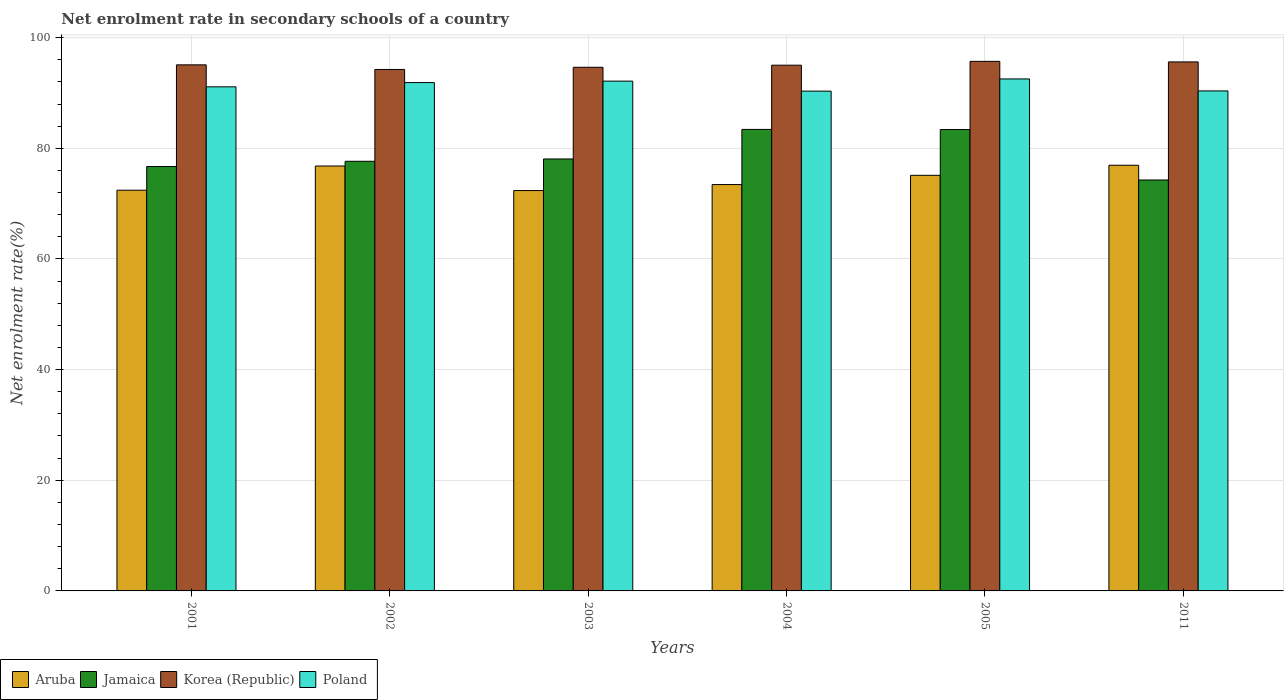Are the number of bars on each tick of the X-axis equal?
Your answer should be compact. Yes. How many bars are there on the 4th tick from the left?
Provide a succinct answer. 4. How many bars are there on the 3rd tick from the right?
Offer a very short reply. 4. What is the label of the 3rd group of bars from the left?
Your answer should be very brief. 2003. What is the net enrolment rate in secondary schools in Korea (Republic) in 2003?
Keep it short and to the point. 94.64. Across all years, what is the maximum net enrolment rate in secondary schools in Korea (Republic)?
Ensure brevity in your answer.  95.71. Across all years, what is the minimum net enrolment rate in secondary schools in Poland?
Keep it short and to the point. 90.33. What is the total net enrolment rate in secondary schools in Aruba in the graph?
Keep it short and to the point. 447.08. What is the difference between the net enrolment rate in secondary schools in Jamaica in 2001 and that in 2002?
Your response must be concise. -0.95. What is the difference between the net enrolment rate in secondary schools in Korea (Republic) in 2005 and the net enrolment rate in secondary schools in Jamaica in 2001?
Your response must be concise. 19.01. What is the average net enrolment rate in secondary schools in Aruba per year?
Ensure brevity in your answer.  74.51. In the year 2003, what is the difference between the net enrolment rate in secondary schools in Korea (Republic) and net enrolment rate in secondary schools in Aruba?
Your response must be concise. 22.28. What is the ratio of the net enrolment rate in secondary schools in Jamaica in 2004 to that in 2005?
Your response must be concise. 1. Is the net enrolment rate in secondary schools in Jamaica in 2004 less than that in 2011?
Your response must be concise. No. What is the difference between the highest and the second highest net enrolment rate in secondary schools in Korea (Republic)?
Your answer should be compact. 0.1. What is the difference between the highest and the lowest net enrolment rate in secondary schools in Aruba?
Offer a very short reply. 4.58. In how many years, is the net enrolment rate in secondary schools in Jamaica greater than the average net enrolment rate in secondary schools in Jamaica taken over all years?
Ensure brevity in your answer.  2. Is the sum of the net enrolment rate in secondary schools in Korea (Republic) in 2001 and 2011 greater than the maximum net enrolment rate in secondary schools in Poland across all years?
Offer a very short reply. Yes. Is it the case that in every year, the sum of the net enrolment rate in secondary schools in Korea (Republic) and net enrolment rate in secondary schools in Poland is greater than the sum of net enrolment rate in secondary schools in Jamaica and net enrolment rate in secondary schools in Aruba?
Your response must be concise. Yes. What does the 2nd bar from the left in 2011 represents?
Provide a succinct answer. Jamaica. What does the 3rd bar from the right in 2002 represents?
Your response must be concise. Jamaica. How many bars are there?
Keep it short and to the point. 24. What is the difference between two consecutive major ticks on the Y-axis?
Ensure brevity in your answer.  20. Are the values on the major ticks of Y-axis written in scientific E-notation?
Offer a terse response. No. Does the graph contain any zero values?
Your answer should be very brief. No. Where does the legend appear in the graph?
Make the answer very short. Bottom left. How are the legend labels stacked?
Offer a terse response. Horizontal. What is the title of the graph?
Provide a short and direct response. Net enrolment rate in secondary schools of a country. Does "Virgin Islands" appear as one of the legend labels in the graph?
Your answer should be compact. No. What is the label or title of the Y-axis?
Your response must be concise. Net enrolment rate(%). What is the Net enrolment rate(%) in Aruba in 2001?
Your response must be concise. 72.42. What is the Net enrolment rate(%) in Jamaica in 2001?
Provide a succinct answer. 76.7. What is the Net enrolment rate(%) in Korea (Republic) in 2001?
Provide a succinct answer. 95.08. What is the Net enrolment rate(%) in Poland in 2001?
Your answer should be very brief. 91.11. What is the Net enrolment rate(%) of Aruba in 2002?
Provide a short and direct response. 76.8. What is the Net enrolment rate(%) of Jamaica in 2002?
Your answer should be compact. 77.65. What is the Net enrolment rate(%) of Korea (Republic) in 2002?
Offer a terse response. 94.25. What is the Net enrolment rate(%) of Poland in 2002?
Offer a very short reply. 91.88. What is the Net enrolment rate(%) in Aruba in 2003?
Provide a short and direct response. 72.36. What is the Net enrolment rate(%) of Jamaica in 2003?
Provide a succinct answer. 78.07. What is the Net enrolment rate(%) of Korea (Republic) in 2003?
Ensure brevity in your answer.  94.64. What is the Net enrolment rate(%) of Poland in 2003?
Your answer should be very brief. 92.14. What is the Net enrolment rate(%) in Aruba in 2004?
Ensure brevity in your answer.  73.44. What is the Net enrolment rate(%) of Jamaica in 2004?
Provide a short and direct response. 83.41. What is the Net enrolment rate(%) in Korea (Republic) in 2004?
Make the answer very short. 95.02. What is the Net enrolment rate(%) of Poland in 2004?
Your answer should be very brief. 90.33. What is the Net enrolment rate(%) of Aruba in 2005?
Give a very brief answer. 75.11. What is the Net enrolment rate(%) of Jamaica in 2005?
Provide a succinct answer. 83.39. What is the Net enrolment rate(%) in Korea (Republic) in 2005?
Ensure brevity in your answer.  95.71. What is the Net enrolment rate(%) in Poland in 2005?
Your answer should be compact. 92.53. What is the Net enrolment rate(%) of Aruba in 2011?
Offer a very short reply. 76.94. What is the Net enrolment rate(%) of Jamaica in 2011?
Your answer should be very brief. 74.27. What is the Net enrolment rate(%) in Korea (Republic) in 2011?
Ensure brevity in your answer.  95.61. What is the Net enrolment rate(%) in Poland in 2011?
Your answer should be very brief. 90.37. Across all years, what is the maximum Net enrolment rate(%) in Aruba?
Make the answer very short. 76.94. Across all years, what is the maximum Net enrolment rate(%) in Jamaica?
Offer a very short reply. 83.41. Across all years, what is the maximum Net enrolment rate(%) in Korea (Republic)?
Your answer should be compact. 95.71. Across all years, what is the maximum Net enrolment rate(%) in Poland?
Keep it short and to the point. 92.53. Across all years, what is the minimum Net enrolment rate(%) of Aruba?
Your response must be concise. 72.36. Across all years, what is the minimum Net enrolment rate(%) of Jamaica?
Provide a short and direct response. 74.27. Across all years, what is the minimum Net enrolment rate(%) in Korea (Republic)?
Provide a short and direct response. 94.25. Across all years, what is the minimum Net enrolment rate(%) of Poland?
Give a very brief answer. 90.33. What is the total Net enrolment rate(%) of Aruba in the graph?
Offer a very short reply. 447.08. What is the total Net enrolment rate(%) in Jamaica in the graph?
Your answer should be compact. 473.5. What is the total Net enrolment rate(%) of Korea (Republic) in the graph?
Offer a very short reply. 570.31. What is the total Net enrolment rate(%) of Poland in the graph?
Ensure brevity in your answer.  548.36. What is the difference between the Net enrolment rate(%) of Aruba in 2001 and that in 2002?
Ensure brevity in your answer.  -4.37. What is the difference between the Net enrolment rate(%) in Jamaica in 2001 and that in 2002?
Your answer should be very brief. -0.95. What is the difference between the Net enrolment rate(%) in Korea (Republic) in 2001 and that in 2002?
Make the answer very short. 0.83. What is the difference between the Net enrolment rate(%) in Poland in 2001 and that in 2002?
Keep it short and to the point. -0.77. What is the difference between the Net enrolment rate(%) of Aruba in 2001 and that in 2003?
Provide a succinct answer. 0.06. What is the difference between the Net enrolment rate(%) in Jamaica in 2001 and that in 2003?
Ensure brevity in your answer.  -1.37. What is the difference between the Net enrolment rate(%) in Korea (Republic) in 2001 and that in 2003?
Make the answer very short. 0.44. What is the difference between the Net enrolment rate(%) of Poland in 2001 and that in 2003?
Keep it short and to the point. -1.03. What is the difference between the Net enrolment rate(%) in Aruba in 2001 and that in 2004?
Give a very brief answer. -1.02. What is the difference between the Net enrolment rate(%) of Jamaica in 2001 and that in 2004?
Your answer should be compact. -6.71. What is the difference between the Net enrolment rate(%) in Korea (Republic) in 2001 and that in 2004?
Your answer should be compact. 0.06. What is the difference between the Net enrolment rate(%) of Poland in 2001 and that in 2004?
Keep it short and to the point. 0.78. What is the difference between the Net enrolment rate(%) in Aruba in 2001 and that in 2005?
Your answer should be compact. -2.69. What is the difference between the Net enrolment rate(%) of Jamaica in 2001 and that in 2005?
Provide a short and direct response. -6.69. What is the difference between the Net enrolment rate(%) of Korea (Republic) in 2001 and that in 2005?
Offer a terse response. -0.63. What is the difference between the Net enrolment rate(%) in Poland in 2001 and that in 2005?
Your response must be concise. -1.42. What is the difference between the Net enrolment rate(%) in Aruba in 2001 and that in 2011?
Your answer should be compact. -4.51. What is the difference between the Net enrolment rate(%) in Jamaica in 2001 and that in 2011?
Ensure brevity in your answer.  2.43. What is the difference between the Net enrolment rate(%) of Korea (Republic) in 2001 and that in 2011?
Your answer should be compact. -0.53. What is the difference between the Net enrolment rate(%) of Poland in 2001 and that in 2011?
Offer a terse response. 0.74. What is the difference between the Net enrolment rate(%) in Aruba in 2002 and that in 2003?
Keep it short and to the point. 4.44. What is the difference between the Net enrolment rate(%) of Jamaica in 2002 and that in 2003?
Make the answer very short. -0.42. What is the difference between the Net enrolment rate(%) of Korea (Republic) in 2002 and that in 2003?
Your answer should be compact. -0.39. What is the difference between the Net enrolment rate(%) in Poland in 2002 and that in 2003?
Provide a short and direct response. -0.26. What is the difference between the Net enrolment rate(%) of Aruba in 2002 and that in 2004?
Ensure brevity in your answer.  3.35. What is the difference between the Net enrolment rate(%) of Jamaica in 2002 and that in 2004?
Keep it short and to the point. -5.76. What is the difference between the Net enrolment rate(%) of Korea (Republic) in 2002 and that in 2004?
Keep it short and to the point. -0.77. What is the difference between the Net enrolment rate(%) of Poland in 2002 and that in 2004?
Provide a short and direct response. 1.54. What is the difference between the Net enrolment rate(%) in Aruba in 2002 and that in 2005?
Your answer should be compact. 1.68. What is the difference between the Net enrolment rate(%) in Jamaica in 2002 and that in 2005?
Your answer should be compact. -5.74. What is the difference between the Net enrolment rate(%) of Korea (Republic) in 2002 and that in 2005?
Offer a very short reply. -1.46. What is the difference between the Net enrolment rate(%) in Poland in 2002 and that in 2005?
Provide a succinct answer. -0.66. What is the difference between the Net enrolment rate(%) in Aruba in 2002 and that in 2011?
Your answer should be compact. -0.14. What is the difference between the Net enrolment rate(%) in Jamaica in 2002 and that in 2011?
Provide a succinct answer. 3.38. What is the difference between the Net enrolment rate(%) of Korea (Republic) in 2002 and that in 2011?
Offer a terse response. -1.36. What is the difference between the Net enrolment rate(%) in Poland in 2002 and that in 2011?
Offer a very short reply. 1.51. What is the difference between the Net enrolment rate(%) in Aruba in 2003 and that in 2004?
Keep it short and to the point. -1.08. What is the difference between the Net enrolment rate(%) of Jamaica in 2003 and that in 2004?
Offer a very short reply. -5.34. What is the difference between the Net enrolment rate(%) in Korea (Republic) in 2003 and that in 2004?
Your answer should be very brief. -0.38. What is the difference between the Net enrolment rate(%) of Poland in 2003 and that in 2004?
Your response must be concise. 1.81. What is the difference between the Net enrolment rate(%) in Aruba in 2003 and that in 2005?
Give a very brief answer. -2.75. What is the difference between the Net enrolment rate(%) in Jamaica in 2003 and that in 2005?
Keep it short and to the point. -5.32. What is the difference between the Net enrolment rate(%) of Korea (Republic) in 2003 and that in 2005?
Provide a succinct answer. -1.07. What is the difference between the Net enrolment rate(%) in Poland in 2003 and that in 2005?
Ensure brevity in your answer.  -0.39. What is the difference between the Net enrolment rate(%) of Aruba in 2003 and that in 2011?
Make the answer very short. -4.58. What is the difference between the Net enrolment rate(%) of Jamaica in 2003 and that in 2011?
Make the answer very short. 3.8. What is the difference between the Net enrolment rate(%) of Korea (Republic) in 2003 and that in 2011?
Your answer should be compact. -0.97. What is the difference between the Net enrolment rate(%) of Poland in 2003 and that in 2011?
Your answer should be very brief. 1.77. What is the difference between the Net enrolment rate(%) of Aruba in 2004 and that in 2005?
Provide a succinct answer. -1.67. What is the difference between the Net enrolment rate(%) of Jamaica in 2004 and that in 2005?
Offer a very short reply. 0.02. What is the difference between the Net enrolment rate(%) in Korea (Republic) in 2004 and that in 2005?
Provide a succinct answer. -0.7. What is the difference between the Net enrolment rate(%) in Poland in 2004 and that in 2005?
Give a very brief answer. -2.2. What is the difference between the Net enrolment rate(%) of Aruba in 2004 and that in 2011?
Make the answer very short. -3.49. What is the difference between the Net enrolment rate(%) in Jamaica in 2004 and that in 2011?
Provide a succinct answer. 9.14. What is the difference between the Net enrolment rate(%) in Korea (Republic) in 2004 and that in 2011?
Offer a very short reply. -0.59. What is the difference between the Net enrolment rate(%) in Poland in 2004 and that in 2011?
Your answer should be compact. -0.04. What is the difference between the Net enrolment rate(%) in Aruba in 2005 and that in 2011?
Provide a short and direct response. -1.82. What is the difference between the Net enrolment rate(%) in Jamaica in 2005 and that in 2011?
Provide a succinct answer. 9.12. What is the difference between the Net enrolment rate(%) in Korea (Republic) in 2005 and that in 2011?
Ensure brevity in your answer.  0.1. What is the difference between the Net enrolment rate(%) in Poland in 2005 and that in 2011?
Give a very brief answer. 2.17. What is the difference between the Net enrolment rate(%) in Aruba in 2001 and the Net enrolment rate(%) in Jamaica in 2002?
Your answer should be compact. -5.23. What is the difference between the Net enrolment rate(%) in Aruba in 2001 and the Net enrolment rate(%) in Korea (Republic) in 2002?
Keep it short and to the point. -21.82. What is the difference between the Net enrolment rate(%) in Aruba in 2001 and the Net enrolment rate(%) in Poland in 2002?
Offer a terse response. -19.45. What is the difference between the Net enrolment rate(%) in Jamaica in 2001 and the Net enrolment rate(%) in Korea (Republic) in 2002?
Provide a succinct answer. -17.54. What is the difference between the Net enrolment rate(%) in Jamaica in 2001 and the Net enrolment rate(%) in Poland in 2002?
Offer a terse response. -15.17. What is the difference between the Net enrolment rate(%) in Korea (Republic) in 2001 and the Net enrolment rate(%) in Poland in 2002?
Keep it short and to the point. 3.2. What is the difference between the Net enrolment rate(%) in Aruba in 2001 and the Net enrolment rate(%) in Jamaica in 2003?
Keep it short and to the point. -5.65. What is the difference between the Net enrolment rate(%) in Aruba in 2001 and the Net enrolment rate(%) in Korea (Republic) in 2003?
Provide a succinct answer. -22.22. What is the difference between the Net enrolment rate(%) in Aruba in 2001 and the Net enrolment rate(%) in Poland in 2003?
Provide a succinct answer. -19.71. What is the difference between the Net enrolment rate(%) of Jamaica in 2001 and the Net enrolment rate(%) of Korea (Republic) in 2003?
Offer a very short reply. -17.94. What is the difference between the Net enrolment rate(%) in Jamaica in 2001 and the Net enrolment rate(%) in Poland in 2003?
Keep it short and to the point. -15.43. What is the difference between the Net enrolment rate(%) in Korea (Republic) in 2001 and the Net enrolment rate(%) in Poland in 2003?
Give a very brief answer. 2.94. What is the difference between the Net enrolment rate(%) of Aruba in 2001 and the Net enrolment rate(%) of Jamaica in 2004?
Give a very brief answer. -10.99. What is the difference between the Net enrolment rate(%) in Aruba in 2001 and the Net enrolment rate(%) in Korea (Republic) in 2004?
Your answer should be compact. -22.59. What is the difference between the Net enrolment rate(%) in Aruba in 2001 and the Net enrolment rate(%) in Poland in 2004?
Your answer should be compact. -17.91. What is the difference between the Net enrolment rate(%) of Jamaica in 2001 and the Net enrolment rate(%) of Korea (Republic) in 2004?
Your response must be concise. -18.31. What is the difference between the Net enrolment rate(%) in Jamaica in 2001 and the Net enrolment rate(%) in Poland in 2004?
Ensure brevity in your answer.  -13.63. What is the difference between the Net enrolment rate(%) of Korea (Republic) in 2001 and the Net enrolment rate(%) of Poland in 2004?
Your response must be concise. 4.75. What is the difference between the Net enrolment rate(%) in Aruba in 2001 and the Net enrolment rate(%) in Jamaica in 2005?
Make the answer very short. -10.97. What is the difference between the Net enrolment rate(%) in Aruba in 2001 and the Net enrolment rate(%) in Korea (Republic) in 2005?
Make the answer very short. -23.29. What is the difference between the Net enrolment rate(%) of Aruba in 2001 and the Net enrolment rate(%) of Poland in 2005?
Make the answer very short. -20.11. What is the difference between the Net enrolment rate(%) of Jamaica in 2001 and the Net enrolment rate(%) of Korea (Republic) in 2005?
Offer a terse response. -19.01. What is the difference between the Net enrolment rate(%) of Jamaica in 2001 and the Net enrolment rate(%) of Poland in 2005?
Your answer should be very brief. -15.83. What is the difference between the Net enrolment rate(%) of Korea (Republic) in 2001 and the Net enrolment rate(%) of Poland in 2005?
Provide a short and direct response. 2.55. What is the difference between the Net enrolment rate(%) in Aruba in 2001 and the Net enrolment rate(%) in Jamaica in 2011?
Make the answer very short. -1.85. What is the difference between the Net enrolment rate(%) in Aruba in 2001 and the Net enrolment rate(%) in Korea (Republic) in 2011?
Make the answer very short. -23.19. What is the difference between the Net enrolment rate(%) in Aruba in 2001 and the Net enrolment rate(%) in Poland in 2011?
Your answer should be compact. -17.94. What is the difference between the Net enrolment rate(%) of Jamaica in 2001 and the Net enrolment rate(%) of Korea (Republic) in 2011?
Offer a very short reply. -18.91. What is the difference between the Net enrolment rate(%) in Jamaica in 2001 and the Net enrolment rate(%) in Poland in 2011?
Make the answer very short. -13.66. What is the difference between the Net enrolment rate(%) of Korea (Republic) in 2001 and the Net enrolment rate(%) of Poland in 2011?
Provide a succinct answer. 4.71. What is the difference between the Net enrolment rate(%) in Aruba in 2002 and the Net enrolment rate(%) in Jamaica in 2003?
Your answer should be compact. -1.28. What is the difference between the Net enrolment rate(%) in Aruba in 2002 and the Net enrolment rate(%) in Korea (Republic) in 2003?
Your response must be concise. -17.85. What is the difference between the Net enrolment rate(%) of Aruba in 2002 and the Net enrolment rate(%) of Poland in 2003?
Keep it short and to the point. -15.34. What is the difference between the Net enrolment rate(%) of Jamaica in 2002 and the Net enrolment rate(%) of Korea (Republic) in 2003?
Make the answer very short. -16.99. What is the difference between the Net enrolment rate(%) of Jamaica in 2002 and the Net enrolment rate(%) of Poland in 2003?
Your answer should be compact. -14.49. What is the difference between the Net enrolment rate(%) of Korea (Republic) in 2002 and the Net enrolment rate(%) of Poland in 2003?
Your response must be concise. 2.11. What is the difference between the Net enrolment rate(%) in Aruba in 2002 and the Net enrolment rate(%) in Jamaica in 2004?
Provide a succinct answer. -6.62. What is the difference between the Net enrolment rate(%) of Aruba in 2002 and the Net enrolment rate(%) of Korea (Republic) in 2004?
Your response must be concise. -18.22. What is the difference between the Net enrolment rate(%) in Aruba in 2002 and the Net enrolment rate(%) in Poland in 2004?
Your answer should be compact. -13.54. What is the difference between the Net enrolment rate(%) of Jamaica in 2002 and the Net enrolment rate(%) of Korea (Republic) in 2004?
Make the answer very short. -17.37. What is the difference between the Net enrolment rate(%) in Jamaica in 2002 and the Net enrolment rate(%) in Poland in 2004?
Make the answer very short. -12.68. What is the difference between the Net enrolment rate(%) of Korea (Republic) in 2002 and the Net enrolment rate(%) of Poland in 2004?
Make the answer very short. 3.92. What is the difference between the Net enrolment rate(%) of Aruba in 2002 and the Net enrolment rate(%) of Jamaica in 2005?
Your response must be concise. -6.6. What is the difference between the Net enrolment rate(%) in Aruba in 2002 and the Net enrolment rate(%) in Korea (Republic) in 2005?
Your answer should be compact. -18.92. What is the difference between the Net enrolment rate(%) of Aruba in 2002 and the Net enrolment rate(%) of Poland in 2005?
Provide a short and direct response. -15.74. What is the difference between the Net enrolment rate(%) of Jamaica in 2002 and the Net enrolment rate(%) of Korea (Republic) in 2005?
Give a very brief answer. -18.06. What is the difference between the Net enrolment rate(%) of Jamaica in 2002 and the Net enrolment rate(%) of Poland in 2005?
Your answer should be very brief. -14.88. What is the difference between the Net enrolment rate(%) in Korea (Republic) in 2002 and the Net enrolment rate(%) in Poland in 2005?
Make the answer very short. 1.71. What is the difference between the Net enrolment rate(%) in Aruba in 2002 and the Net enrolment rate(%) in Jamaica in 2011?
Provide a succinct answer. 2.53. What is the difference between the Net enrolment rate(%) in Aruba in 2002 and the Net enrolment rate(%) in Korea (Republic) in 2011?
Keep it short and to the point. -18.81. What is the difference between the Net enrolment rate(%) in Aruba in 2002 and the Net enrolment rate(%) in Poland in 2011?
Ensure brevity in your answer.  -13.57. What is the difference between the Net enrolment rate(%) of Jamaica in 2002 and the Net enrolment rate(%) of Korea (Republic) in 2011?
Your answer should be compact. -17.96. What is the difference between the Net enrolment rate(%) of Jamaica in 2002 and the Net enrolment rate(%) of Poland in 2011?
Offer a very short reply. -12.72. What is the difference between the Net enrolment rate(%) in Korea (Republic) in 2002 and the Net enrolment rate(%) in Poland in 2011?
Provide a short and direct response. 3.88. What is the difference between the Net enrolment rate(%) in Aruba in 2003 and the Net enrolment rate(%) in Jamaica in 2004?
Keep it short and to the point. -11.05. What is the difference between the Net enrolment rate(%) in Aruba in 2003 and the Net enrolment rate(%) in Korea (Republic) in 2004?
Ensure brevity in your answer.  -22.66. What is the difference between the Net enrolment rate(%) of Aruba in 2003 and the Net enrolment rate(%) of Poland in 2004?
Ensure brevity in your answer.  -17.97. What is the difference between the Net enrolment rate(%) of Jamaica in 2003 and the Net enrolment rate(%) of Korea (Republic) in 2004?
Provide a succinct answer. -16.95. What is the difference between the Net enrolment rate(%) in Jamaica in 2003 and the Net enrolment rate(%) in Poland in 2004?
Ensure brevity in your answer.  -12.26. What is the difference between the Net enrolment rate(%) of Korea (Republic) in 2003 and the Net enrolment rate(%) of Poland in 2004?
Offer a very short reply. 4.31. What is the difference between the Net enrolment rate(%) of Aruba in 2003 and the Net enrolment rate(%) of Jamaica in 2005?
Provide a succinct answer. -11.03. What is the difference between the Net enrolment rate(%) of Aruba in 2003 and the Net enrolment rate(%) of Korea (Republic) in 2005?
Offer a very short reply. -23.35. What is the difference between the Net enrolment rate(%) in Aruba in 2003 and the Net enrolment rate(%) in Poland in 2005?
Provide a short and direct response. -20.17. What is the difference between the Net enrolment rate(%) in Jamaica in 2003 and the Net enrolment rate(%) in Korea (Republic) in 2005?
Ensure brevity in your answer.  -17.64. What is the difference between the Net enrolment rate(%) in Jamaica in 2003 and the Net enrolment rate(%) in Poland in 2005?
Your answer should be compact. -14.46. What is the difference between the Net enrolment rate(%) of Korea (Republic) in 2003 and the Net enrolment rate(%) of Poland in 2005?
Ensure brevity in your answer.  2.11. What is the difference between the Net enrolment rate(%) of Aruba in 2003 and the Net enrolment rate(%) of Jamaica in 2011?
Your response must be concise. -1.91. What is the difference between the Net enrolment rate(%) of Aruba in 2003 and the Net enrolment rate(%) of Korea (Republic) in 2011?
Offer a very short reply. -23.25. What is the difference between the Net enrolment rate(%) of Aruba in 2003 and the Net enrolment rate(%) of Poland in 2011?
Offer a terse response. -18.01. What is the difference between the Net enrolment rate(%) of Jamaica in 2003 and the Net enrolment rate(%) of Korea (Republic) in 2011?
Your answer should be compact. -17.54. What is the difference between the Net enrolment rate(%) in Jamaica in 2003 and the Net enrolment rate(%) in Poland in 2011?
Offer a very short reply. -12.29. What is the difference between the Net enrolment rate(%) of Korea (Republic) in 2003 and the Net enrolment rate(%) of Poland in 2011?
Provide a succinct answer. 4.28. What is the difference between the Net enrolment rate(%) in Aruba in 2004 and the Net enrolment rate(%) in Jamaica in 2005?
Provide a short and direct response. -9.95. What is the difference between the Net enrolment rate(%) of Aruba in 2004 and the Net enrolment rate(%) of Korea (Republic) in 2005?
Keep it short and to the point. -22.27. What is the difference between the Net enrolment rate(%) of Aruba in 2004 and the Net enrolment rate(%) of Poland in 2005?
Ensure brevity in your answer.  -19.09. What is the difference between the Net enrolment rate(%) of Jamaica in 2004 and the Net enrolment rate(%) of Korea (Republic) in 2005?
Make the answer very short. -12.3. What is the difference between the Net enrolment rate(%) of Jamaica in 2004 and the Net enrolment rate(%) of Poland in 2005?
Offer a terse response. -9.12. What is the difference between the Net enrolment rate(%) in Korea (Republic) in 2004 and the Net enrolment rate(%) in Poland in 2005?
Give a very brief answer. 2.48. What is the difference between the Net enrolment rate(%) in Aruba in 2004 and the Net enrolment rate(%) in Jamaica in 2011?
Your answer should be very brief. -0.82. What is the difference between the Net enrolment rate(%) of Aruba in 2004 and the Net enrolment rate(%) of Korea (Republic) in 2011?
Ensure brevity in your answer.  -22.16. What is the difference between the Net enrolment rate(%) in Aruba in 2004 and the Net enrolment rate(%) in Poland in 2011?
Provide a short and direct response. -16.92. What is the difference between the Net enrolment rate(%) in Jamaica in 2004 and the Net enrolment rate(%) in Korea (Republic) in 2011?
Ensure brevity in your answer.  -12.2. What is the difference between the Net enrolment rate(%) in Jamaica in 2004 and the Net enrolment rate(%) in Poland in 2011?
Make the answer very short. -6.95. What is the difference between the Net enrolment rate(%) in Korea (Republic) in 2004 and the Net enrolment rate(%) in Poland in 2011?
Ensure brevity in your answer.  4.65. What is the difference between the Net enrolment rate(%) of Aruba in 2005 and the Net enrolment rate(%) of Jamaica in 2011?
Offer a very short reply. 0.85. What is the difference between the Net enrolment rate(%) in Aruba in 2005 and the Net enrolment rate(%) in Korea (Republic) in 2011?
Your answer should be compact. -20.5. What is the difference between the Net enrolment rate(%) of Aruba in 2005 and the Net enrolment rate(%) of Poland in 2011?
Ensure brevity in your answer.  -15.25. What is the difference between the Net enrolment rate(%) of Jamaica in 2005 and the Net enrolment rate(%) of Korea (Republic) in 2011?
Give a very brief answer. -12.22. What is the difference between the Net enrolment rate(%) in Jamaica in 2005 and the Net enrolment rate(%) in Poland in 2011?
Offer a very short reply. -6.97. What is the difference between the Net enrolment rate(%) of Korea (Republic) in 2005 and the Net enrolment rate(%) of Poland in 2011?
Keep it short and to the point. 5.35. What is the average Net enrolment rate(%) of Aruba per year?
Keep it short and to the point. 74.51. What is the average Net enrolment rate(%) in Jamaica per year?
Your answer should be compact. 78.92. What is the average Net enrolment rate(%) of Korea (Republic) per year?
Your response must be concise. 95.05. What is the average Net enrolment rate(%) in Poland per year?
Provide a succinct answer. 91.39. In the year 2001, what is the difference between the Net enrolment rate(%) of Aruba and Net enrolment rate(%) of Jamaica?
Make the answer very short. -4.28. In the year 2001, what is the difference between the Net enrolment rate(%) in Aruba and Net enrolment rate(%) in Korea (Republic)?
Your answer should be very brief. -22.66. In the year 2001, what is the difference between the Net enrolment rate(%) of Aruba and Net enrolment rate(%) of Poland?
Ensure brevity in your answer.  -18.69. In the year 2001, what is the difference between the Net enrolment rate(%) in Jamaica and Net enrolment rate(%) in Korea (Republic)?
Provide a succinct answer. -18.38. In the year 2001, what is the difference between the Net enrolment rate(%) in Jamaica and Net enrolment rate(%) in Poland?
Provide a succinct answer. -14.41. In the year 2001, what is the difference between the Net enrolment rate(%) in Korea (Republic) and Net enrolment rate(%) in Poland?
Provide a short and direct response. 3.97. In the year 2002, what is the difference between the Net enrolment rate(%) in Aruba and Net enrolment rate(%) in Jamaica?
Offer a terse response. -0.85. In the year 2002, what is the difference between the Net enrolment rate(%) in Aruba and Net enrolment rate(%) in Korea (Republic)?
Provide a succinct answer. -17.45. In the year 2002, what is the difference between the Net enrolment rate(%) of Aruba and Net enrolment rate(%) of Poland?
Your response must be concise. -15.08. In the year 2002, what is the difference between the Net enrolment rate(%) of Jamaica and Net enrolment rate(%) of Korea (Republic)?
Your answer should be compact. -16.6. In the year 2002, what is the difference between the Net enrolment rate(%) of Jamaica and Net enrolment rate(%) of Poland?
Ensure brevity in your answer.  -14.22. In the year 2002, what is the difference between the Net enrolment rate(%) of Korea (Republic) and Net enrolment rate(%) of Poland?
Your answer should be very brief. 2.37. In the year 2003, what is the difference between the Net enrolment rate(%) in Aruba and Net enrolment rate(%) in Jamaica?
Your answer should be very brief. -5.71. In the year 2003, what is the difference between the Net enrolment rate(%) of Aruba and Net enrolment rate(%) of Korea (Republic)?
Your answer should be compact. -22.28. In the year 2003, what is the difference between the Net enrolment rate(%) in Aruba and Net enrolment rate(%) in Poland?
Make the answer very short. -19.78. In the year 2003, what is the difference between the Net enrolment rate(%) in Jamaica and Net enrolment rate(%) in Korea (Republic)?
Offer a very short reply. -16.57. In the year 2003, what is the difference between the Net enrolment rate(%) in Jamaica and Net enrolment rate(%) in Poland?
Ensure brevity in your answer.  -14.07. In the year 2003, what is the difference between the Net enrolment rate(%) in Korea (Republic) and Net enrolment rate(%) in Poland?
Your answer should be compact. 2.5. In the year 2004, what is the difference between the Net enrolment rate(%) of Aruba and Net enrolment rate(%) of Jamaica?
Keep it short and to the point. -9.97. In the year 2004, what is the difference between the Net enrolment rate(%) in Aruba and Net enrolment rate(%) in Korea (Republic)?
Your answer should be compact. -21.57. In the year 2004, what is the difference between the Net enrolment rate(%) of Aruba and Net enrolment rate(%) of Poland?
Offer a terse response. -16.89. In the year 2004, what is the difference between the Net enrolment rate(%) in Jamaica and Net enrolment rate(%) in Korea (Republic)?
Provide a succinct answer. -11.61. In the year 2004, what is the difference between the Net enrolment rate(%) of Jamaica and Net enrolment rate(%) of Poland?
Offer a very short reply. -6.92. In the year 2004, what is the difference between the Net enrolment rate(%) in Korea (Republic) and Net enrolment rate(%) in Poland?
Offer a terse response. 4.69. In the year 2005, what is the difference between the Net enrolment rate(%) in Aruba and Net enrolment rate(%) in Jamaica?
Keep it short and to the point. -8.28. In the year 2005, what is the difference between the Net enrolment rate(%) in Aruba and Net enrolment rate(%) in Korea (Republic)?
Provide a succinct answer. -20.6. In the year 2005, what is the difference between the Net enrolment rate(%) in Aruba and Net enrolment rate(%) in Poland?
Make the answer very short. -17.42. In the year 2005, what is the difference between the Net enrolment rate(%) of Jamaica and Net enrolment rate(%) of Korea (Republic)?
Your response must be concise. -12.32. In the year 2005, what is the difference between the Net enrolment rate(%) in Jamaica and Net enrolment rate(%) in Poland?
Offer a very short reply. -9.14. In the year 2005, what is the difference between the Net enrolment rate(%) of Korea (Republic) and Net enrolment rate(%) of Poland?
Give a very brief answer. 3.18. In the year 2011, what is the difference between the Net enrolment rate(%) in Aruba and Net enrolment rate(%) in Jamaica?
Give a very brief answer. 2.67. In the year 2011, what is the difference between the Net enrolment rate(%) of Aruba and Net enrolment rate(%) of Korea (Republic)?
Your answer should be very brief. -18.67. In the year 2011, what is the difference between the Net enrolment rate(%) in Aruba and Net enrolment rate(%) in Poland?
Your answer should be very brief. -13.43. In the year 2011, what is the difference between the Net enrolment rate(%) in Jamaica and Net enrolment rate(%) in Korea (Republic)?
Offer a very short reply. -21.34. In the year 2011, what is the difference between the Net enrolment rate(%) of Jamaica and Net enrolment rate(%) of Poland?
Provide a succinct answer. -16.1. In the year 2011, what is the difference between the Net enrolment rate(%) of Korea (Republic) and Net enrolment rate(%) of Poland?
Make the answer very short. 5.24. What is the ratio of the Net enrolment rate(%) in Aruba in 2001 to that in 2002?
Keep it short and to the point. 0.94. What is the ratio of the Net enrolment rate(%) of Jamaica in 2001 to that in 2002?
Ensure brevity in your answer.  0.99. What is the ratio of the Net enrolment rate(%) in Korea (Republic) in 2001 to that in 2002?
Give a very brief answer. 1.01. What is the ratio of the Net enrolment rate(%) in Poland in 2001 to that in 2002?
Provide a short and direct response. 0.99. What is the ratio of the Net enrolment rate(%) of Aruba in 2001 to that in 2003?
Your answer should be compact. 1. What is the ratio of the Net enrolment rate(%) of Jamaica in 2001 to that in 2003?
Ensure brevity in your answer.  0.98. What is the ratio of the Net enrolment rate(%) in Aruba in 2001 to that in 2004?
Keep it short and to the point. 0.99. What is the ratio of the Net enrolment rate(%) in Jamaica in 2001 to that in 2004?
Give a very brief answer. 0.92. What is the ratio of the Net enrolment rate(%) in Korea (Republic) in 2001 to that in 2004?
Ensure brevity in your answer.  1. What is the ratio of the Net enrolment rate(%) of Poland in 2001 to that in 2004?
Keep it short and to the point. 1.01. What is the ratio of the Net enrolment rate(%) of Aruba in 2001 to that in 2005?
Provide a succinct answer. 0.96. What is the ratio of the Net enrolment rate(%) of Jamaica in 2001 to that in 2005?
Provide a short and direct response. 0.92. What is the ratio of the Net enrolment rate(%) of Korea (Republic) in 2001 to that in 2005?
Offer a terse response. 0.99. What is the ratio of the Net enrolment rate(%) in Poland in 2001 to that in 2005?
Give a very brief answer. 0.98. What is the ratio of the Net enrolment rate(%) in Aruba in 2001 to that in 2011?
Your answer should be very brief. 0.94. What is the ratio of the Net enrolment rate(%) of Jamaica in 2001 to that in 2011?
Your answer should be compact. 1.03. What is the ratio of the Net enrolment rate(%) in Korea (Republic) in 2001 to that in 2011?
Keep it short and to the point. 0.99. What is the ratio of the Net enrolment rate(%) in Poland in 2001 to that in 2011?
Your response must be concise. 1.01. What is the ratio of the Net enrolment rate(%) of Aruba in 2002 to that in 2003?
Give a very brief answer. 1.06. What is the ratio of the Net enrolment rate(%) in Poland in 2002 to that in 2003?
Make the answer very short. 1. What is the ratio of the Net enrolment rate(%) of Aruba in 2002 to that in 2004?
Your answer should be very brief. 1.05. What is the ratio of the Net enrolment rate(%) of Jamaica in 2002 to that in 2004?
Your response must be concise. 0.93. What is the ratio of the Net enrolment rate(%) of Korea (Republic) in 2002 to that in 2004?
Offer a terse response. 0.99. What is the ratio of the Net enrolment rate(%) of Poland in 2002 to that in 2004?
Provide a succinct answer. 1.02. What is the ratio of the Net enrolment rate(%) in Aruba in 2002 to that in 2005?
Your response must be concise. 1.02. What is the ratio of the Net enrolment rate(%) of Jamaica in 2002 to that in 2005?
Give a very brief answer. 0.93. What is the ratio of the Net enrolment rate(%) of Korea (Republic) in 2002 to that in 2005?
Offer a terse response. 0.98. What is the ratio of the Net enrolment rate(%) of Aruba in 2002 to that in 2011?
Make the answer very short. 1. What is the ratio of the Net enrolment rate(%) of Jamaica in 2002 to that in 2011?
Offer a very short reply. 1.05. What is the ratio of the Net enrolment rate(%) of Korea (Republic) in 2002 to that in 2011?
Ensure brevity in your answer.  0.99. What is the ratio of the Net enrolment rate(%) in Poland in 2002 to that in 2011?
Give a very brief answer. 1.02. What is the ratio of the Net enrolment rate(%) of Aruba in 2003 to that in 2004?
Offer a very short reply. 0.99. What is the ratio of the Net enrolment rate(%) of Jamaica in 2003 to that in 2004?
Your answer should be compact. 0.94. What is the ratio of the Net enrolment rate(%) of Aruba in 2003 to that in 2005?
Your response must be concise. 0.96. What is the ratio of the Net enrolment rate(%) in Jamaica in 2003 to that in 2005?
Give a very brief answer. 0.94. What is the ratio of the Net enrolment rate(%) in Korea (Republic) in 2003 to that in 2005?
Offer a terse response. 0.99. What is the ratio of the Net enrolment rate(%) in Aruba in 2003 to that in 2011?
Provide a succinct answer. 0.94. What is the ratio of the Net enrolment rate(%) in Jamaica in 2003 to that in 2011?
Your answer should be compact. 1.05. What is the ratio of the Net enrolment rate(%) in Poland in 2003 to that in 2011?
Provide a succinct answer. 1.02. What is the ratio of the Net enrolment rate(%) of Aruba in 2004 to that in 2005?
Keep it short and to the point. 0.98. What is the ratio of the Net enrolment rate(%) of Jamaica in 2004 to that in 2005?
Give a very brief answer. 1. What is the ratio of the Net enrolment rate(%) in Poland in 2004 to that in 2005?
Provide a succinct answer. 0.98. What is the ratio of the Net enrolment rate(%) in Aruba in 2004 to that in 2011?
Your answer should be compact. 0.95. What is the ratio of the Net enrolment rate(%) of Jamaica in 2004 to that in 2011?
Give a very brief answer. 1.12. What is the ratio of the Net enrolment rate(%) in Poland in 2004 to that in 2011?
Offer a terse response. 1. What is the ratio of the Net enrolment rate(%) in Aruba in 2005 to that in 2011?
Ensure brevity in your answer.  0.98. What is the ratio of the Net enrolment rate(%) in Jamaica in 2005 to that in 2011?
Give a very brief answer. 1.12. What is the ratio of the Net enrolment rate(%) in Korea (Republic) in 2005 to that in 2011?
Make the answer very short. 1. What is the ratio of the Net enrolment rate(%) of Poland in 2005 to that in 2011?
Your answer should be very brief. 1.02. What is the difference between the highest and the second highest Net enrolment rate(%) in Aruba?
Offer a very short reply. 0.14. What is the difference between the highest and the second highest Net enrolment rate(%) in Jamaica?
Offer a very short reply. 0.02. What is the difference between the highest and the second highest Net enrolment rate(%) in Korea (Republic)?
Offer a very short reply. 0.1. What is the difference between the highest and the second highest Net enrolment rate(%) of Poland?
Provide a short and direct response. 0.39. What is the difference between the highest and the lowest Net enrolment rate(%) in Aruba?
Offer a terse response. 4.58. What is the difference between the highest and the lowest Net enrolment rate(%) of Jamaica?
Give a very brief answer. 9.14. What is the difference between the highest and the lowest Net enrolment rate(%) of Korea (Republic)?
Your response must be concise. 1.46. What is the difference between the highest and the lowest Net enrolment rate(%) in Poland?
Offer a very short reply. 2.2. 